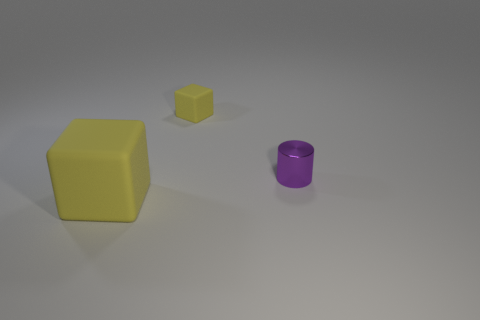Add 2 yellow matte objects. How many objects exist? 5 Subtract all cylinders. How many objects are left? 2 Subtract 2 cubes. How many cubes are left? 0 Subtract all purple cylinders. Subtract all purple objects. How many objects are left? 1 Add 2 small purple cylinders. How many small purple cylinders are left? 3 Add 2 tiny yellow matte cubes. How many tiny yellow matte cubes exist? 3 Subtract 0 red blocks. How many objects are left? 3 Subtract all cyan cubes. Subtract all brown spheres. How many cubes are left? 2 